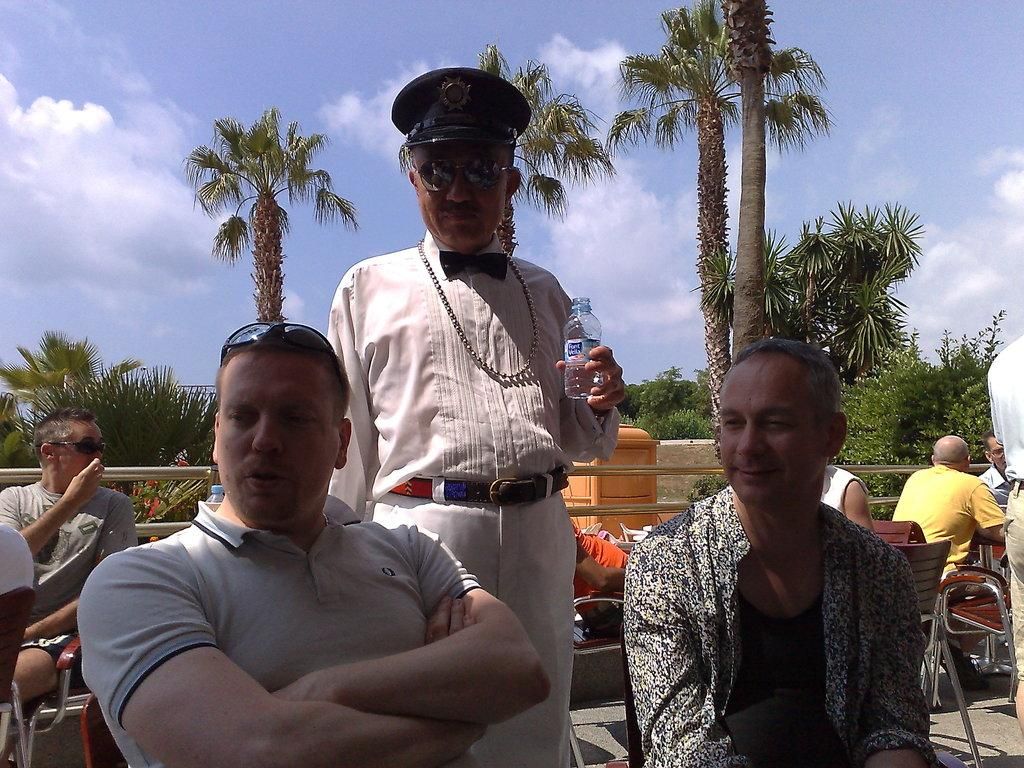How many people are in the image? There are people in the image, but the exact number is not specified. What are some of the people in the image doing? Some people in the image are sitting on chairs. What can be seen in the background of the image? In the background of the image, there are plants, trees, and the sky. What type of meal is being served in the image? There is no meal present in the image. Who is the achiever in the image? There is no mention of an achiever or any achievement in the image. 